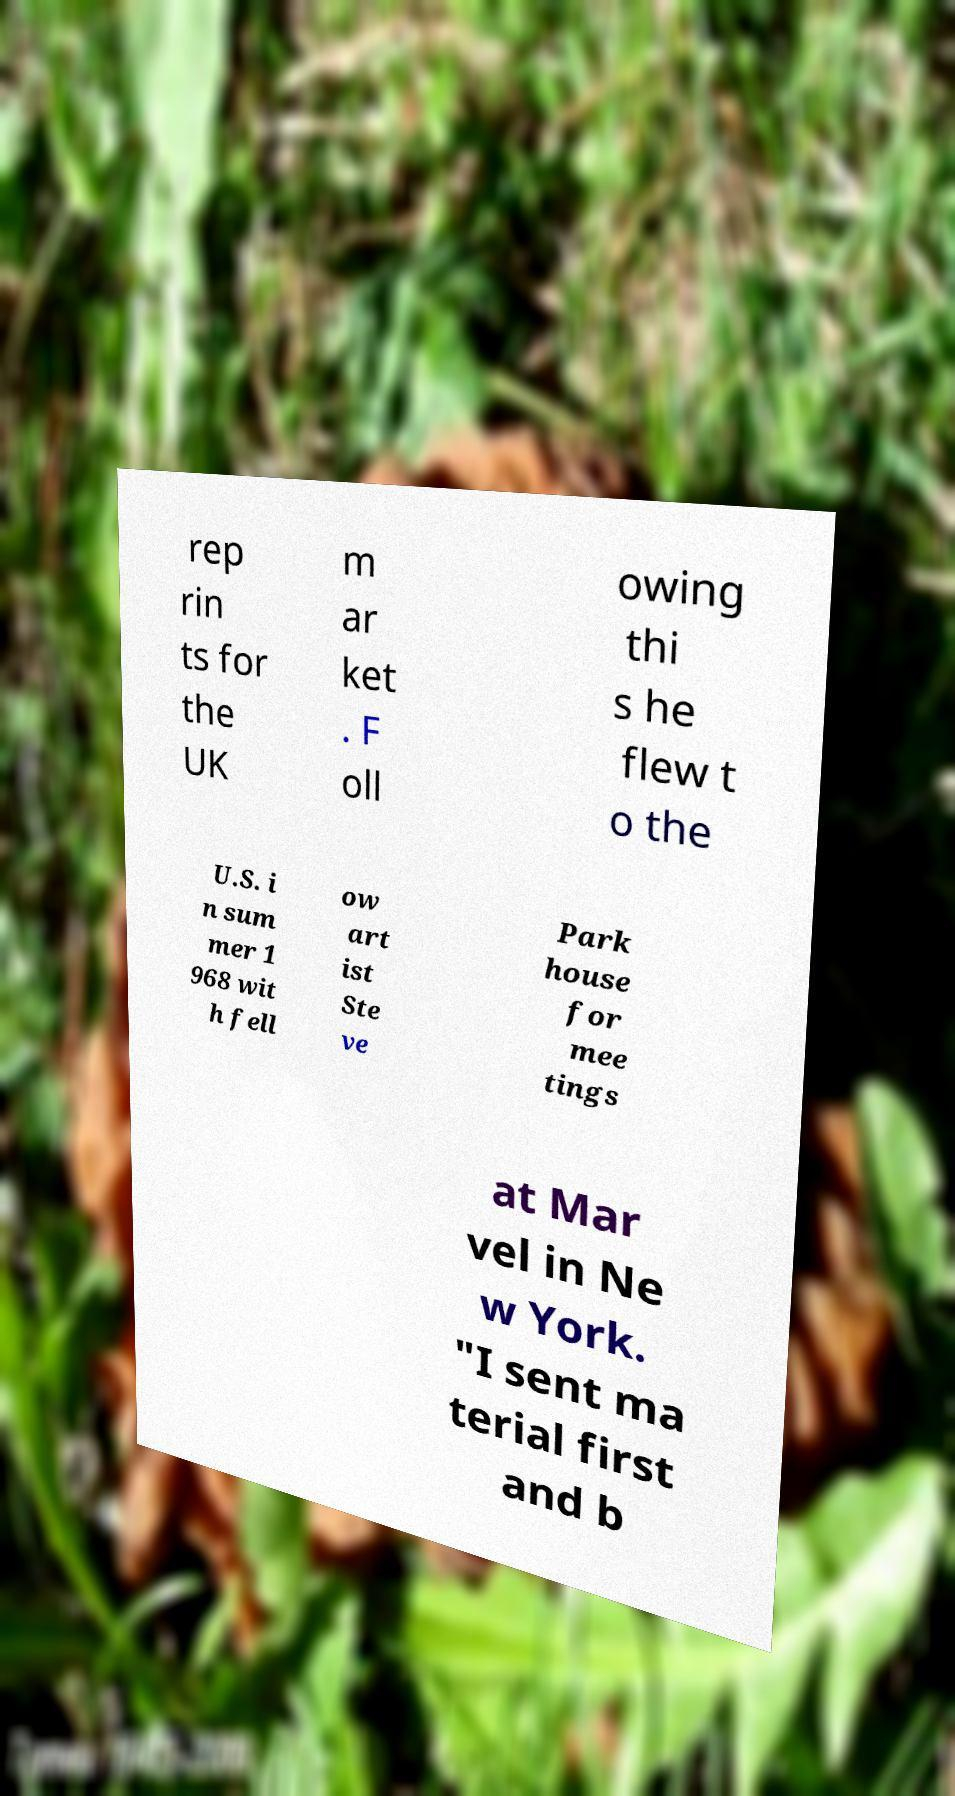For documentation purposes, I need the text within this image transcribed. Could you provide that? rep rin ts for the UK m ar ket . F oll owing thi s he flew t o the U.S. i n sum mer 1 968 wit h fell ow art ist Ste ve Park house for mee tings at Mar vel in Ne w York. "I sent ma terial first and b 